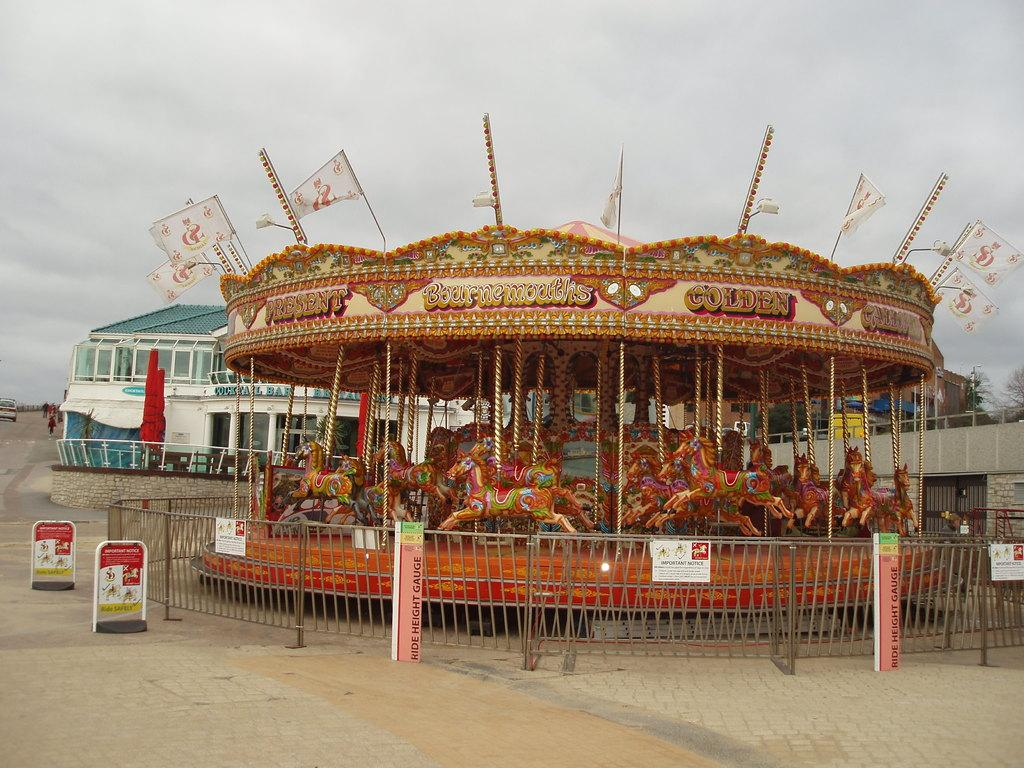What type of ride is in the image? There is a child carousel in the image. What can be seen on the carousel? The image does not show the details of the carousel, but there are boards visible. What structure is in the background of the image? There is a building in the image. What is happening on the road in the image? Vehicles are moving on the road in the image. What decorative elements are present in the image? There are flags in the image. What type of vegetation is present in the image? Trees are present in the image. What is the condition of the sky in the image? The sky in the background is cloudy. How many yaks are pulling the carousel in the image? There are no yaks present in the image; the carousel is likely powered by electricity or manually. 